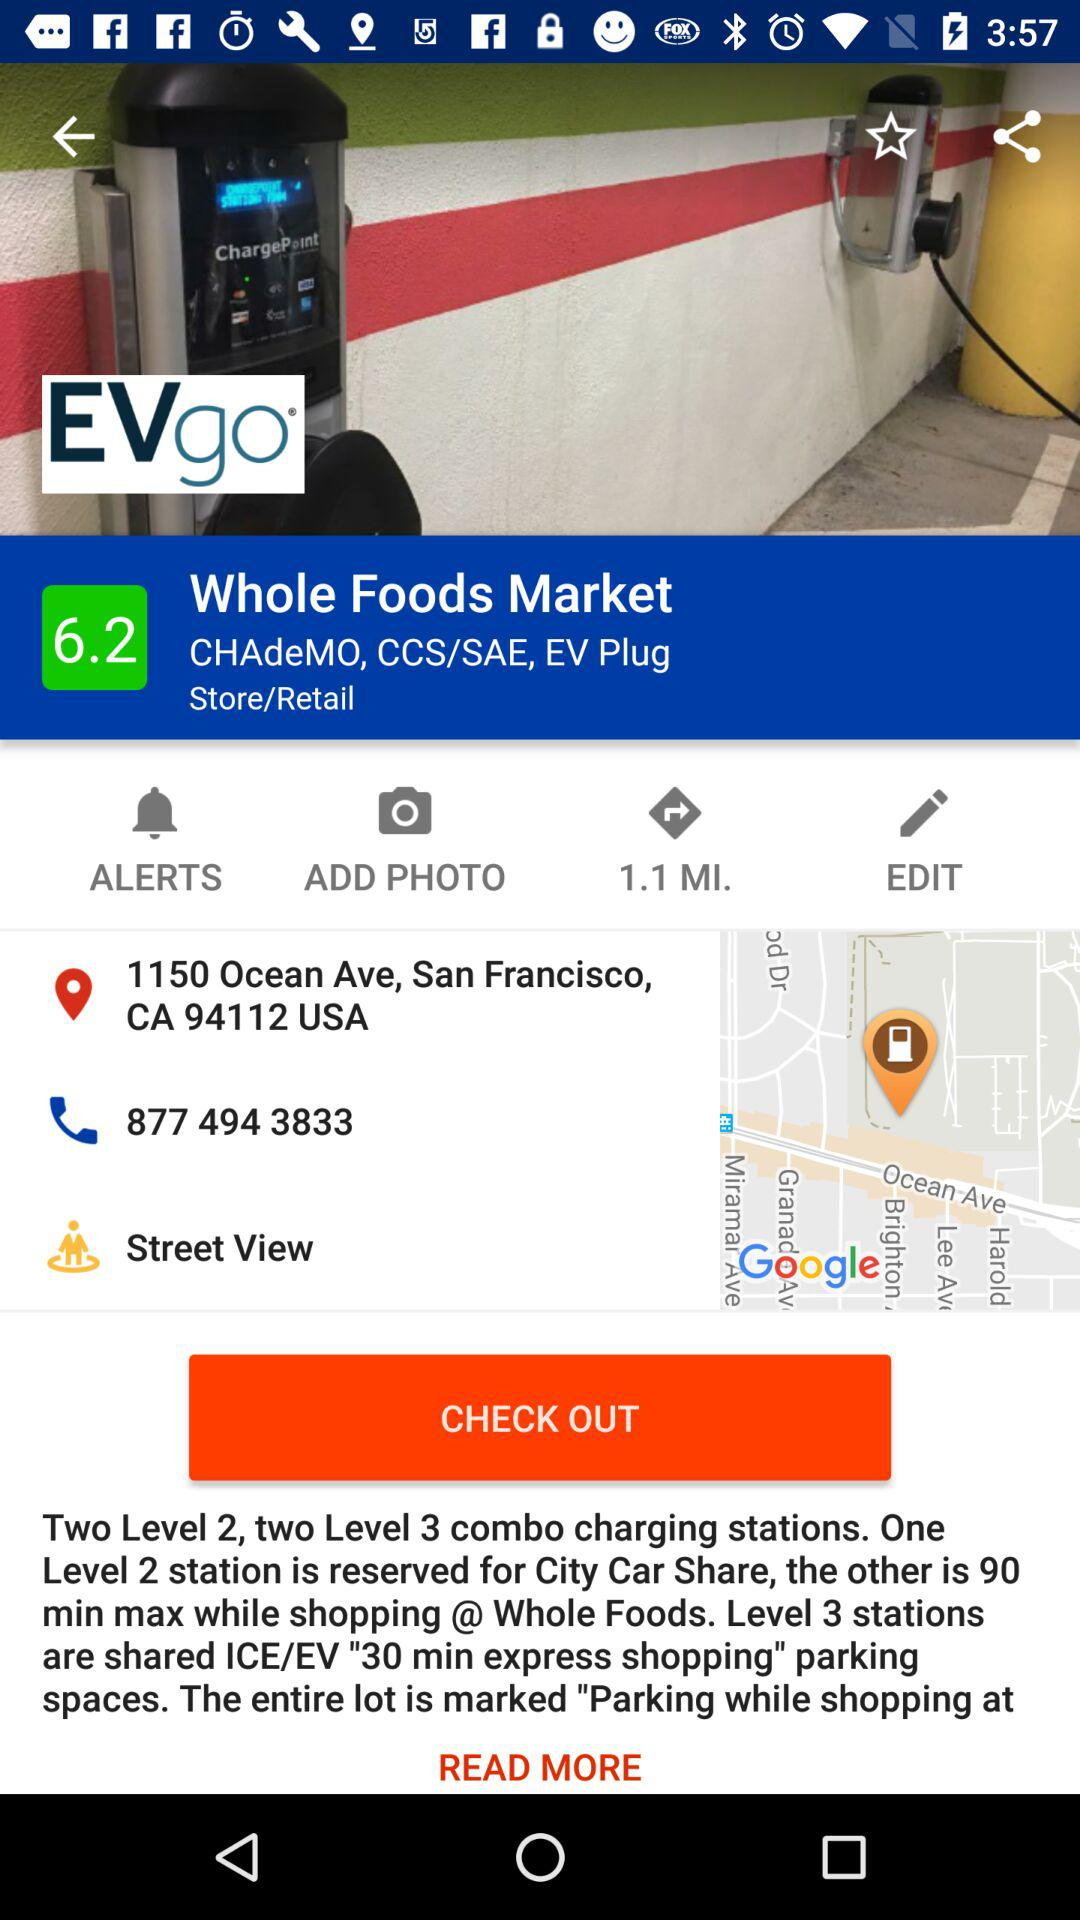How much is the rating? The rating is 6.2. 